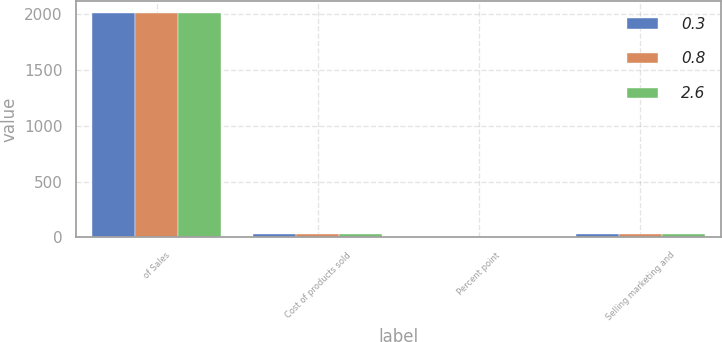Convert chart. <chart><loc_0><loc_0><loc_500><loc_500><stacked_bar_chart><ecel><fcel>of Sales<fcel>Cost of products sold<fcel>Percent point<fcel>Selling marketing and<nl><fcel>0.3<fcel>2017<fcel>33.2<fcel>3<fcel>28<nl><fcel>0.8<fcel>2016<fcel>30.2<fcel>0.5<fcel>27.7<nl><fcel>2.6<fcel>2015<fcel>30.7<fcel>0.1<fcel>30.3<nl></chart> 